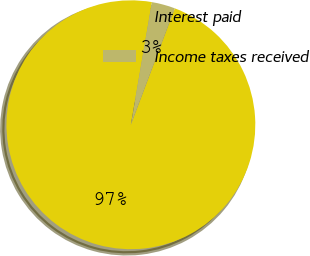Convert chart to OTSL. <chart><loc_0><loc_0><loc_500><loc_500><pie_chart><fcel>Interest paid<fcel>Income taxes received<nl><fcel>96.96%<fcel>3.04%<nl></chart> 